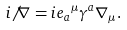<formula> <loc_0><loc_0><loc_500><loc_500>i { \not \, \nabla } = i { e _ { a } } ^ { \mu } { \gamma } ^ { a } \nabla _ { \mu } .</formula> 